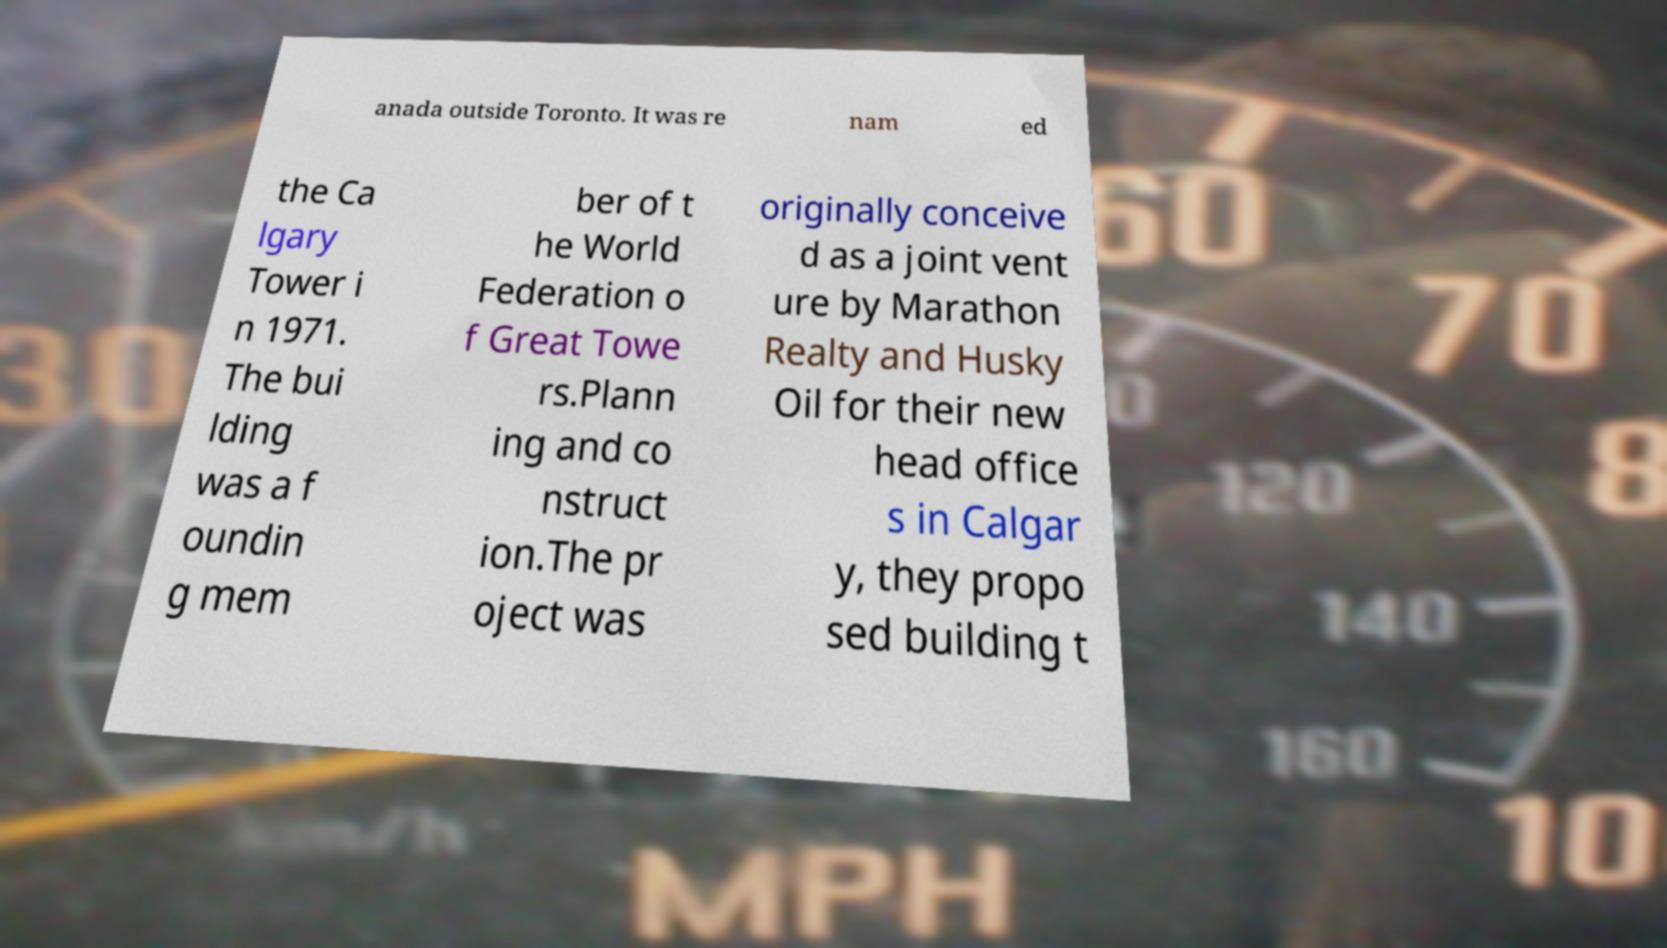Please identify and transcribe the text found in this image. anada outside Toronto. It was re nam ed the Ca lgary Tower i n 1971. The bui lding was a f oundin g mem ber of t he World Federation o f Great Towe rs.Plann ing and co nstruct ion.The pr oject was originally conceive d as a joint vent ure by Marathon Realty and Husky Oil for their new head office s in Calgar y, they propo sed building t 